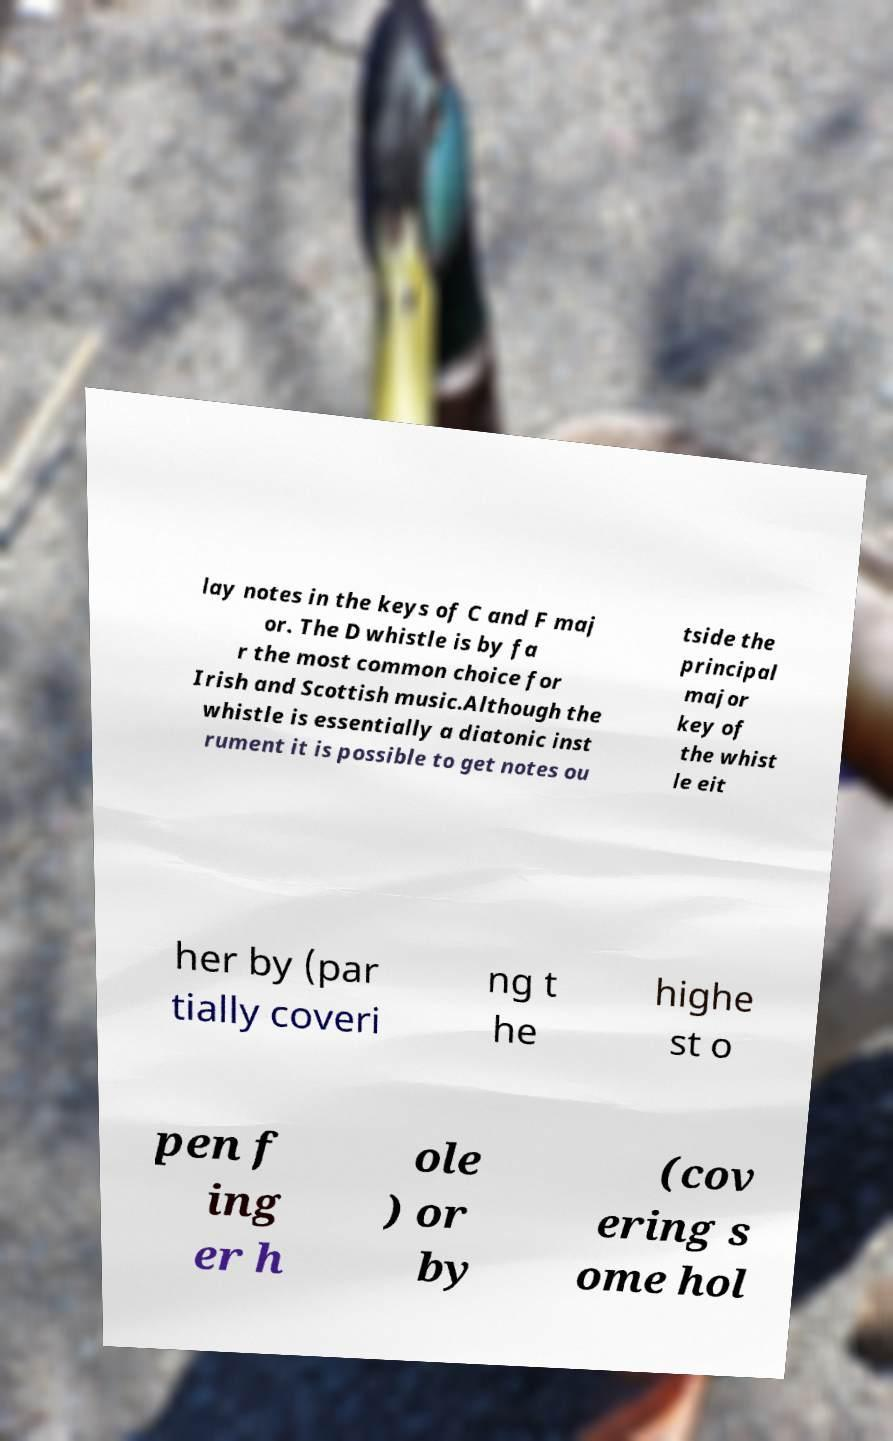Can you read and provide the text displayed in the image?This photo seems to have some interesting text. Can you extract and type it out for me? lay notes in the keys of C and F maj or. The D whistle is by fa r the most common choice for Irish and Scottish music.Although the whistle is essentially a diatonic inst rument it is possible to get notes ou tside the principal major key of the whist le eit her by (par tially coveri ng t he highe st o pen f ing er h ole ) or by (cov ering s ome hol 